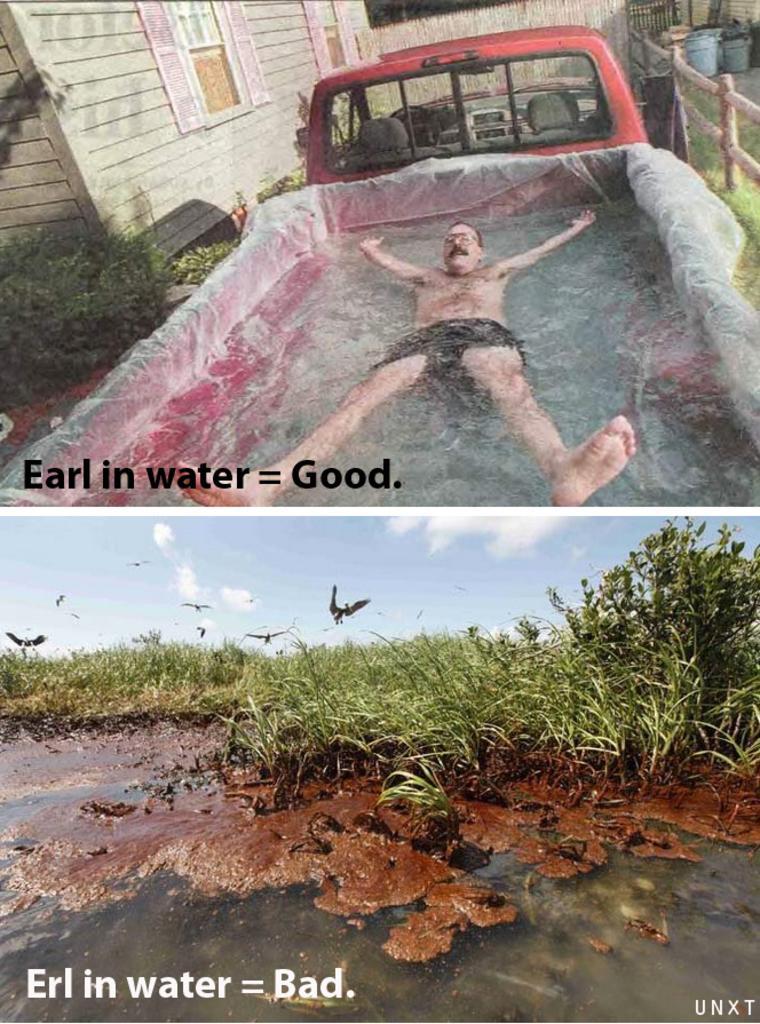How would you summarize this image in a sentence or two? In the picture we can see a two pictures, in the first picture we can see a man sleeping in the water, the water is in the trailer of the truck and in the second picture we can see a grass plant in the water and in the background we can see some birds flying in the air. 